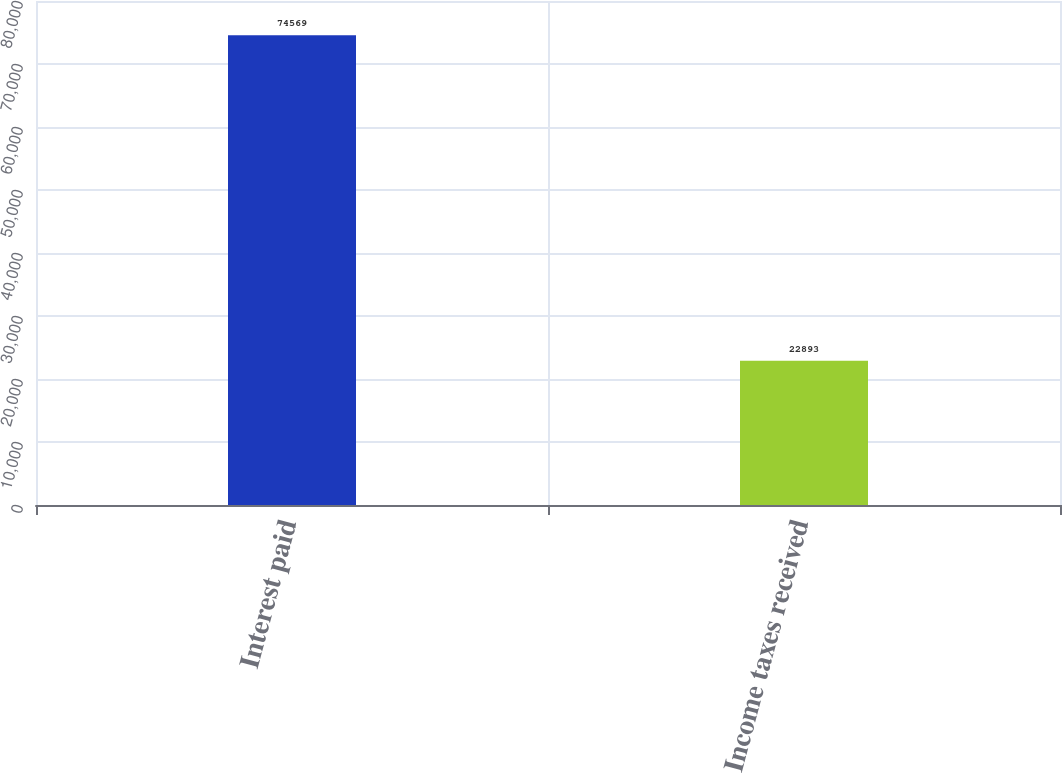<chart> <loc_0><loc_0><loc_500><loc_500><bar_chart><fcel>Interest paid<fcel>Income taxes received<nl><fcel>74569<fcel>22893<nl></chart> 